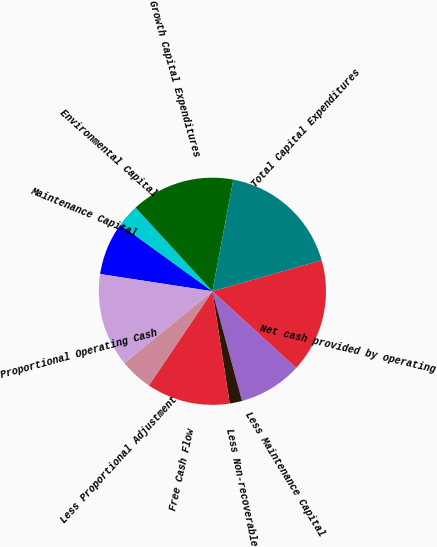Convert chart. <chart><loc_0><loc_0><loc_500><loc_500><pie_chart><fcel>Maintenance Capital<fcel>Environmental Capital<fcel>Growth Capital Expenditures<fcel>Total Capital Expenditures<fcel>Net cash provided by operating<fcel>Less Maintenance Capital<fcel>Less Non-recoverable<fcel>Free Cash Flow<fcel>Less Proportional Adjustment<fcel>Proportional Operating Cash<nl><fcel>7.55%<fcel>3.21%<fcel>14.77%<fcel>17.65%<fcel>16.21%<fcel>8.99%<fcel>1.77%<fcel>11.88%<fcel>4.66%<fcel>13.32%<nl></chart> 